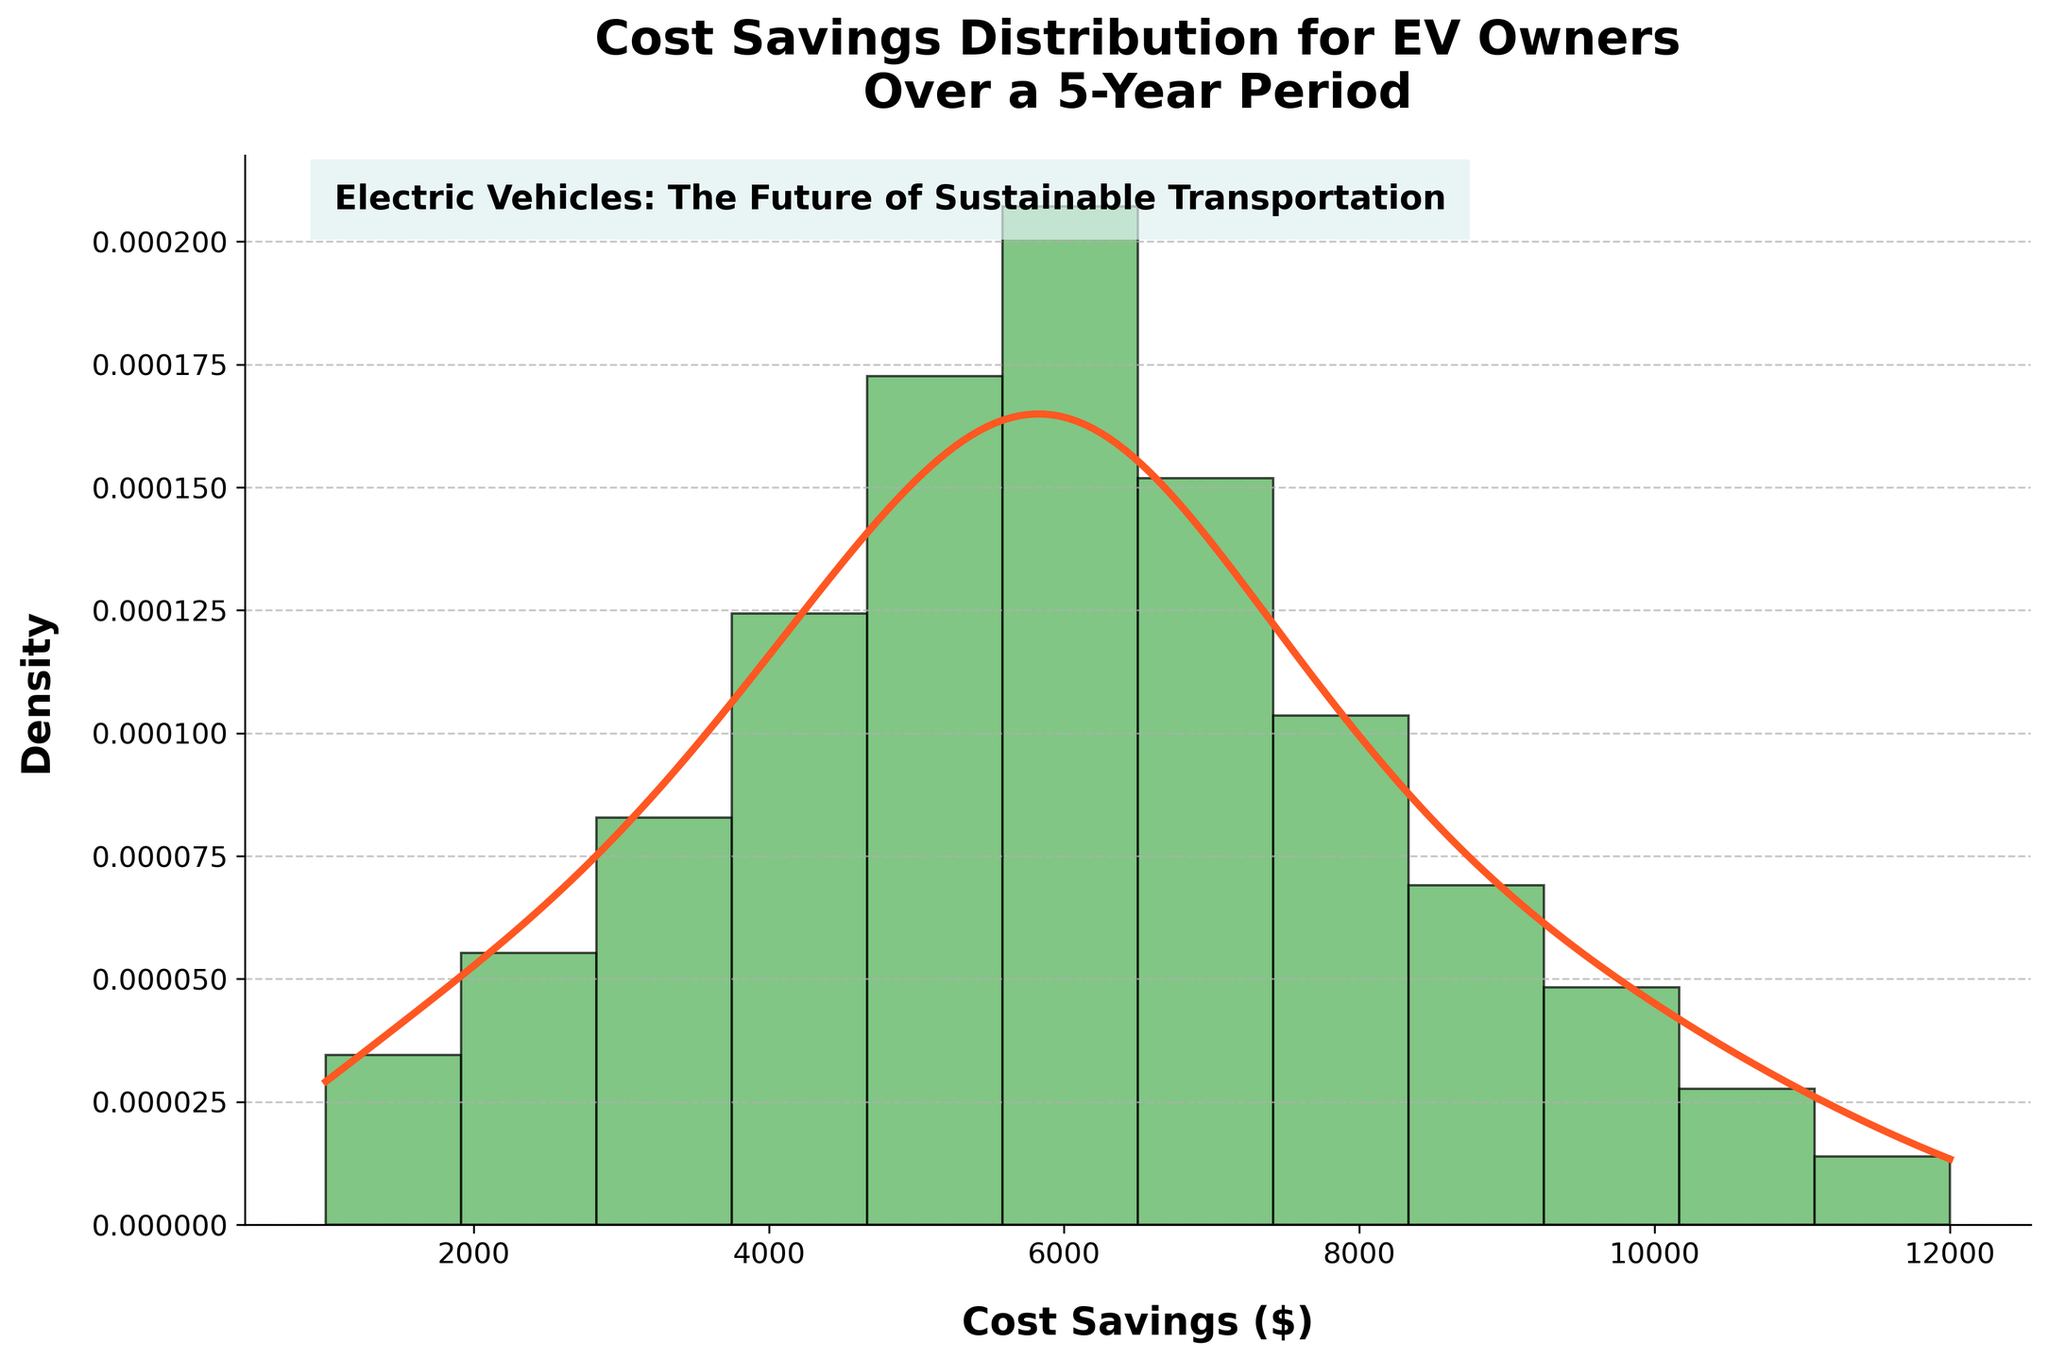What is the title of the figure? The title is located at the top of the figure and reads "Cost Savings Distribution for EV Owners Over a 5-Year Period."
Answer: Cost Savings Distribution for EV Owners Over a 5-Year Period What color is used for the density curve? The density curve is drawn as a line in the figure with a specific color. In this case, it is the color used for the line on the plot.
Answer: Orange (or a specific shade like #FF5722) What are the minimum and maximum values on the x-axis? The x-axis represents the cost savings in dollars. The minimum and maximum values can be observed from the extent of the axis labels.
Answer: 1000 and 12000 dollars At which cost savings value is the peak of the histogram? The peak of the histogram can be identified by looking at which bar is the highest.
Answer: Around 6000 dollars Which cost savings value has the highest density according to the KDE curve? The highest density on the KDE curve is where the curve reaches its maximum value.
Answer: 6000 dollars Estimate the total number of data points used to create the histogram. The total number of data points is the sum of the frequencies provided in the data. Adding them up (5 + 8 + 12 + 18 + 25 + 30 + 22 + 15 + 10 + 7 + 4 + 2) results in the total.
Answer: 158 Which cost savings range contains the most data points? The range with the most data points corresponds to the bar with the highest frequency in the histogram.
Answer: 5000 to 6000 dollars How does the histogram compare to the KDE curve in terms of skewness? Observing if either the histogram or the KDE curve is skewed to the left or right can help compare their skewness. Both shapes can provide insights into the data distribution.
Answer: Both are right-skewed If the cost savings were normally distributed, how would the histogram and KDE curve look different? A normal distribution would have a bell-shaped histogram and KDE curve, centered around a mean value. The histogram and KDE curve currently suggest a different shape.
Answer: They would both be more symmetric and bell-shaped What is the purpose of the histogram with KDE plot in this figure? The purpose of combining a histogram with a KDE curve is to visually represent the distribution of the data. The histogram shows frequency while the KDE curve estimates the probability density.
Answer: To show both the frequency and density of cost savings distribution 